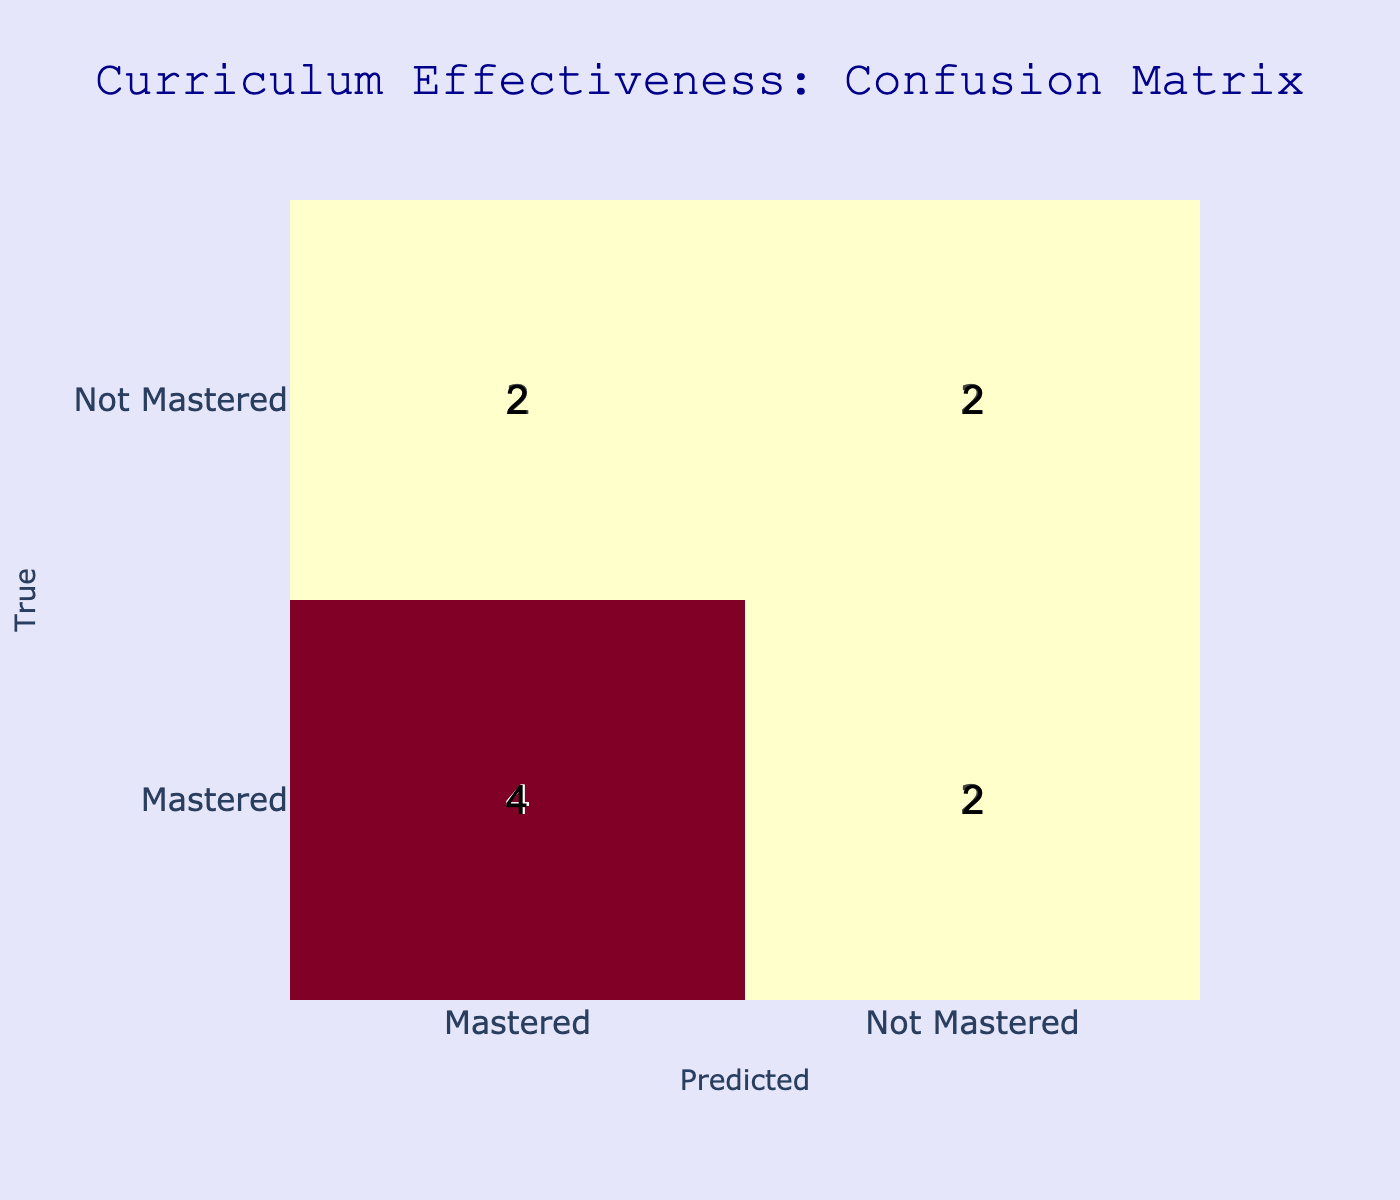What is the total number of students who mastered the skills? We look at the True_Label column and count how many students have the label "Mastered." The students who mastered skills are Michael Smith, Sophia Wilson, William Miller, and Isabella Hernandez, totaling 4 students.
Answer: 4 How many students were predicted to have mastered skills but were not actually mastered? We examine the table for cases where the True_Label is "Mastered" but the Predicted_Label is "Not Mastered." Looking at the data, we find that James Rodriguez is the only student in this category.
Answer: 1 What is the total number of students who did not master the skills? We count the students labeled "Not Mastered" in the True_Label column. The students are Jacob Brown, Ava Davis, Olivia Garcia, and Ethan Lee, totaling 4 students.
Answer: 4 Are there more students who mastered or did not master their skills? To answer this, we compare the counts from the True_Label. There are 4 students who mastered and 4 students who did not master their skills. Since both have equal counts, the answer is they are equal.
Answer: No What percentage of students were incorrectly predicted as 'Not Mastered'? To find this, we calculate the number of students who have mastered skills (4) but were predicted as not mastered (1). The total number of students is 10. Thus, the percentage is (1/10) * 100% = 10%.
Answer: 10% How many students correctly mastered their skills according to the predictions? We look for the instances where both True_Label and Predicted_Label are "Mastered." The students who fall into this category are Michael Smith, Sophia Wilson, William Miller, and Isabella Hernandez, totaling 4 students.
Answer: 4 What is the difference in the number of students who mastered versus those who were predicted to master? Here, we need to find the number of mastered (4) and predicted to master (6). The difference is calculated as 6 - 4 = 2, indicating that 2 more students were predicted to master than actually did.
Answer: 2 Which skill had students that were predicted not to master when they actually did? We need to look for students where the True_Label is "Mastered" and the Predicted_Label is "Not Mastered." The only student that fits this criteria is James Rodriguez with the skill of History.
Answer: James Rodriguez with History What is the total number of accurate predictions made? We count the diagonal elements from the confusion matrix, which corresponds to students who were correctly predicted. Thus, we have 4 mastered and 3 not mastered, giving a total of 7 accurate predictions out of 10 students.
Answer: 7 